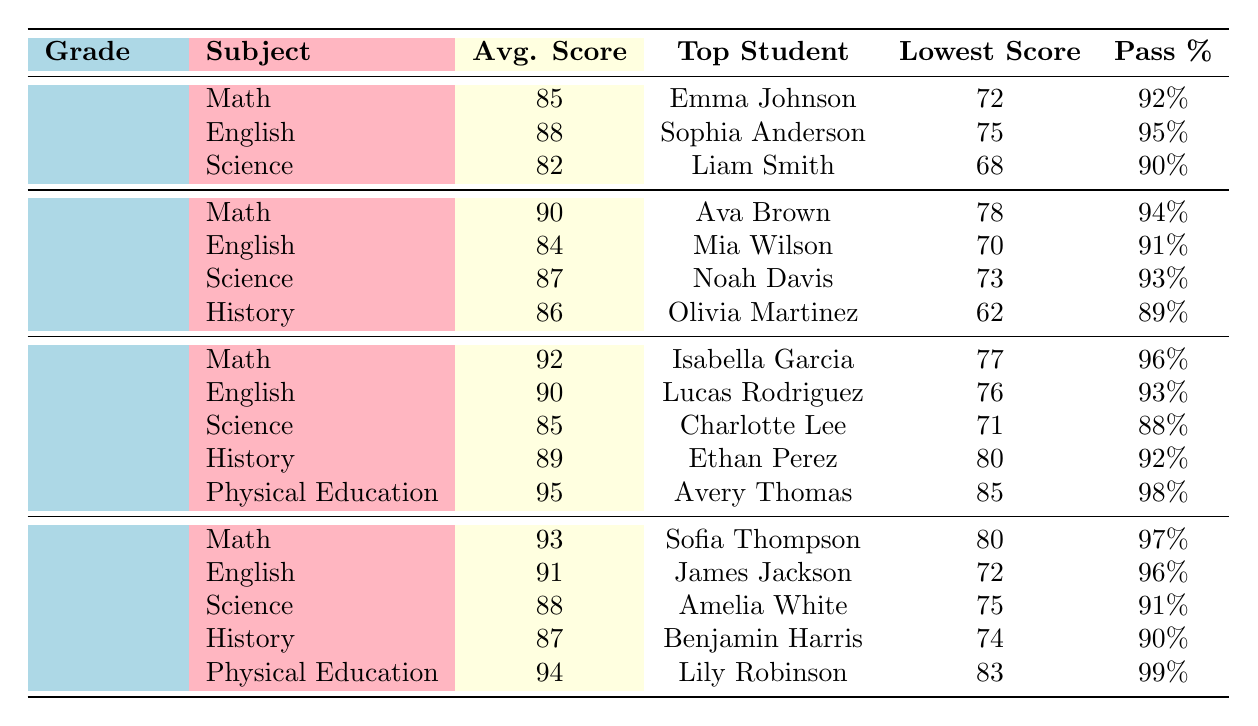What is the average score for Math in Grade 10? The average score for Math in Grade 10 is listed directly in the table under that category, which shows an Average Score of 90.
Answer: 90 Who is the top student in English for Grade 11? The table indicates that the Top Student in English for Grade 11 is Lucas Rodriguez.
Answer: Lucas Rodriguez What is the pass percentage for Science in Grade 12? The pass percentage for Science in Grade 12 is directly provided in the table, showing a Pass Percentage of 91%.
Answer: 91% Which subject in Grade 9 had the lowest average score and what was it? By comparing the average scores for all subjects in Grade 9 (Math: 85, English: 88, Science: 82), Science has the lowest average score at 82.
Answer: Science, 82 Is there a subject in Grade 11 where the pass percentage is above 95%? The table shows the Pass Percentage for each subject in Grade 11 (Math: 96%, English: 93%, Science: 88%, History: 92%, Physical Education: 98%). Since Math, Physical Education, and English all fall above 95%, the answer is yes.
Answer: Yes What is the difference between the top student's score in Science for Grade 10 and the lowest score in History for Grade 10? The top student in Science for Grade 10 is Noah Davis with an Average Score of 87, and the lowest score in History for Grade 10 is 62. The difference is calculated as 87 - 62 = 25.
Answer: 25 Which grade had the highest average score in Physical Education? The table shows that Grade 11 had an Average Score of 95 in Physical Education, while Grade 12 had 94. Therefore, Grade 11 had the highest average score in Physical Education.
Answer: Grade 11 What is the average score for English in Grade 12 compared to all grades listed? The Average Score for English in Grade 12 is 91, and for Grade 11, it's 90; for Grade 10, it's 84; and for Grade 9, it's 88. The average across these grades is (88+84+90+91) = 353/4 = 88.25. Thus, Grade 12 is above the average score.
Answer: Above average How many subjects had a pass percentage of 90% or higher in Grade 9? In Grade 9, the subjects and their pass percentages are as follows: Math: 92%, English: 95%, Science: 90%. All three subjects are above 90%. Therefore, the answer is three.
Answer: Three Is the lowest score in Grade 10 History higher than the lowest score in Grade 12 History? The lowest score in Grade 10 History is 62, while the lowest score in Grade 12 History is 74. Since 62 is not higher than 74, the answer is no.
Answer: No 